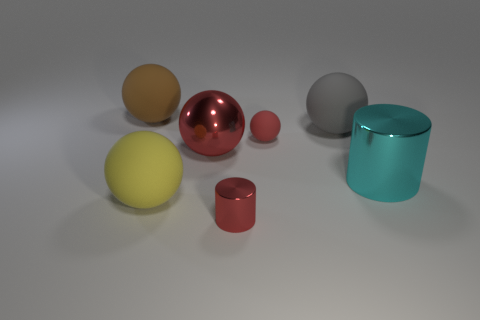Subtract all yellow spheres. How many spheres are left? 4 Subtract all big metallic spheres. How many spheres are left? 4 Subtract all purple balls. Subtract all yellow cubes. How many balls are left? 5 Add 1 big shiny cylinders. How many objects exist? 8 Subtract all cylinders. How many objects are left? 5 Add 5 big yellow matte balls. How many big yellow matte balls are left? 6 Add 4 matte spheres. How many matte spheres exist? 8 Subtract 0 yellow cylinders. How many objects are left? 7 Subtract all big yellow things. Subtract all spheres. How many objects are left? 1 